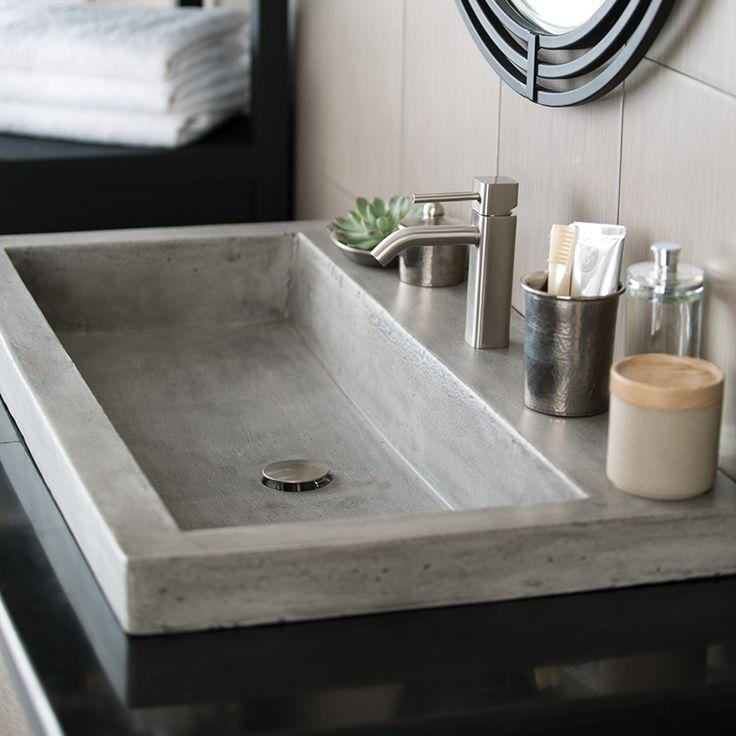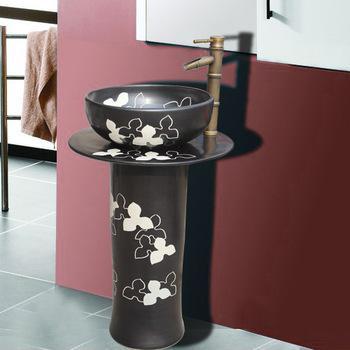The first image is the image on the left, the second image is the image on the right. For the images displayed, is the sentence "There is a silver colored sink, and a not-silver colored sink." factually correct? Answer yes or no. Yes. 